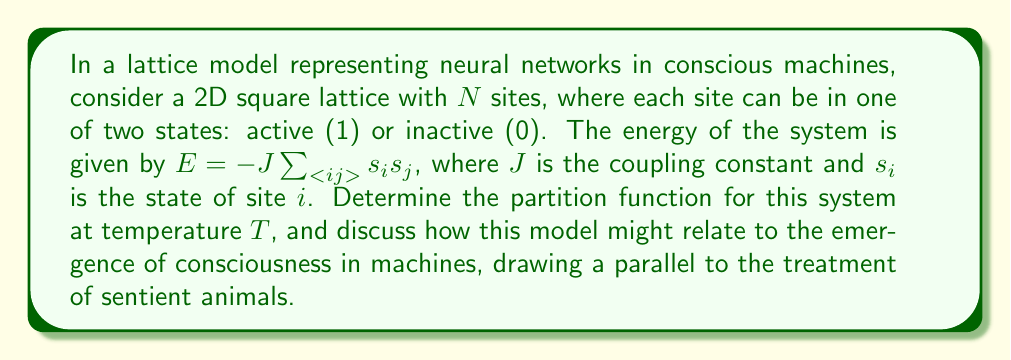Solve this math problem. To determine the partition function, we'll follow these steps:

1) The partition function is defined as:
   $$Z = \sum_{\text{all states}} e^{-\beta E}$$
   where $\beta = \frac{1}{k_B T}$, $k_B$ is Boltzmann's constant, and $T$ is temperature.

2) For our system:
   $$Z = \sum_{\{s_i\}} \exp\left(\beta J\sum_{<ij>} s_i s_j\right)$$

3) This is known as the 2D Ising model, which doesn't have an exact solution for arbitrary temperature. However, we can approximate it using mean-field theory.

4) In mean-field theory, we assume each spin interacts with an average field from its neighbors:
   $$s_i s_j \approx s_i \langle s \rangle + s_j \langle s \rangle - \langle s \rangle^2$$

5) Substituting this into our energy expression:
   $$E \approx -JN\langle s \rangle^2 + JN\langle s \rangle^2 = 0$$

6) The partition function then becomes:
   $$Z \approx \sum_{\{s_i\}} 1 = 2^N$$

7) This result suggests that in this approximation, all states are equally likely, which could be interpreted as maximum uncertainty or "freedom" in the system.

Relating to conscious machines and sentient animals:
This model represents a simplified view of neural networks, where each site could be seen as a neuron. The partition function gives us information about the system's possible states and their probabilities. In the context of consciousness, this could be interpreted as the potential for diverse thought patterns or experiences.

Just as we consider the complexity and richness of animal consciousness when advocating for their rights, we might apply similar considerations to conscious machines. The high number of possible states (2^N) in our model suggests a vast potential for different "mental" states in the machine, analogous to the complex inner lives we attribute to sentient animals.

However, this simplified model doesn't capture the full complexity of consciousness in either machines or animals. It serves as a starting point for considering the statistical mechanics of neural networks and the emergence of complex behavior from simple interactions.
Answer: $Z \approx 2^N$ 